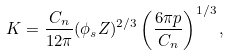Convert formula to latex. <formula><loc_0><loc_0><loc_500><loc_500>K = \frac { C _ { n } } { 1 2 \pi } ( \phi _ { s } Z ) ^ { 2 / 3 } \left ( \frac { 6 \pi p } { C _ { n } } \right ) ^ { 1 / 3 } ,</formula> 